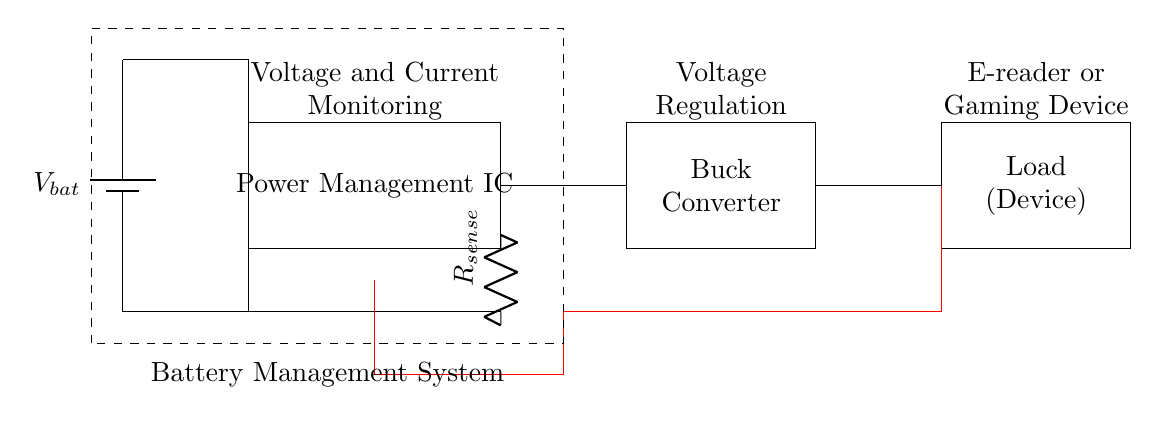What component is responsible for voltage regulation? The Buck Converter is responsible for voltage regulation in the circuit as it steps down the battery voltage to a suitable level for the load, ensuring consistent power delivery.
Answer: Buck Converter What is the purpose of the sense resistor? The sense resistor, labeled as R sense, is used to measure the current flowing through the circuit. By monitoring the voltage across it, the circuit can determine the load current, which is essential for effective power management and optimization of battery life.
Answer: Current measurement What device is indicated as the load? The load in the circuit is represented as the e-reader or gaming device. This indicates that these components are powered by the output from the power management circuit, which provides the necessary voltage and current.
Answer: E-reader or Gaming Device Which component provides voltage and current monitoring? The Power Management IC, located in the middle of the circuit diagram, is responsible for monitoring both voltage and current to manage battery power efficiently and optimize utilization while extending battery life.
Answer: Power Management IC How does the feedback line assist in the circuit? The feedback line connects the load back to the power management circuit and is essential for adjusting the output voltage by relaying real-time data about the load requirements. This feedback loop allows the circuit to maintain efficiency and stability in power delivery.
Answer: Voltage regulation 